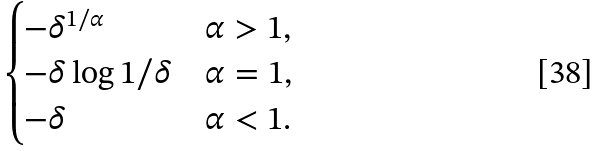Convert formula to latex. <formula><loc_0><loc_0><loc_500><loc_500>\begin{cases} - \delta ^ { 1 / \alpha } & \alpha > 1 , \\ - \delta \log 1 / \delta & \alpha = 1 , \\ - \delta & \alpha < 1 . \end{cases}</formula> 